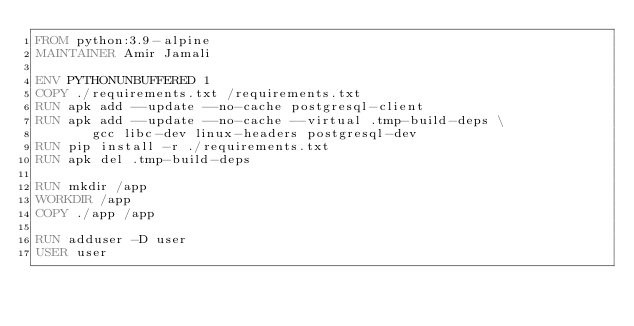Convert code to text. <code><loc_0><loc_0><loc_500><loc_500><_Dockerfile_>FROM python:3.9-alpine
MAINTAINER Amir Jamali

ENV PYTHONUNBUFFERED 1
COPY ./requirements.txt /requirements.txt
RUN apk add --update --no-cache postgresql-client
RUN apk add --update --no-cache --virtual .tmp-build-deps \
       gcc libc-dev linux-headers postgresql-dev
RUN pip install -r ./requirements.txt
RUN apk del .tmp-build-deps 

RUN mkdir /app
WORKDIR /app
COPY ./app /app

RUN adduser -D user
USER user

</code> 